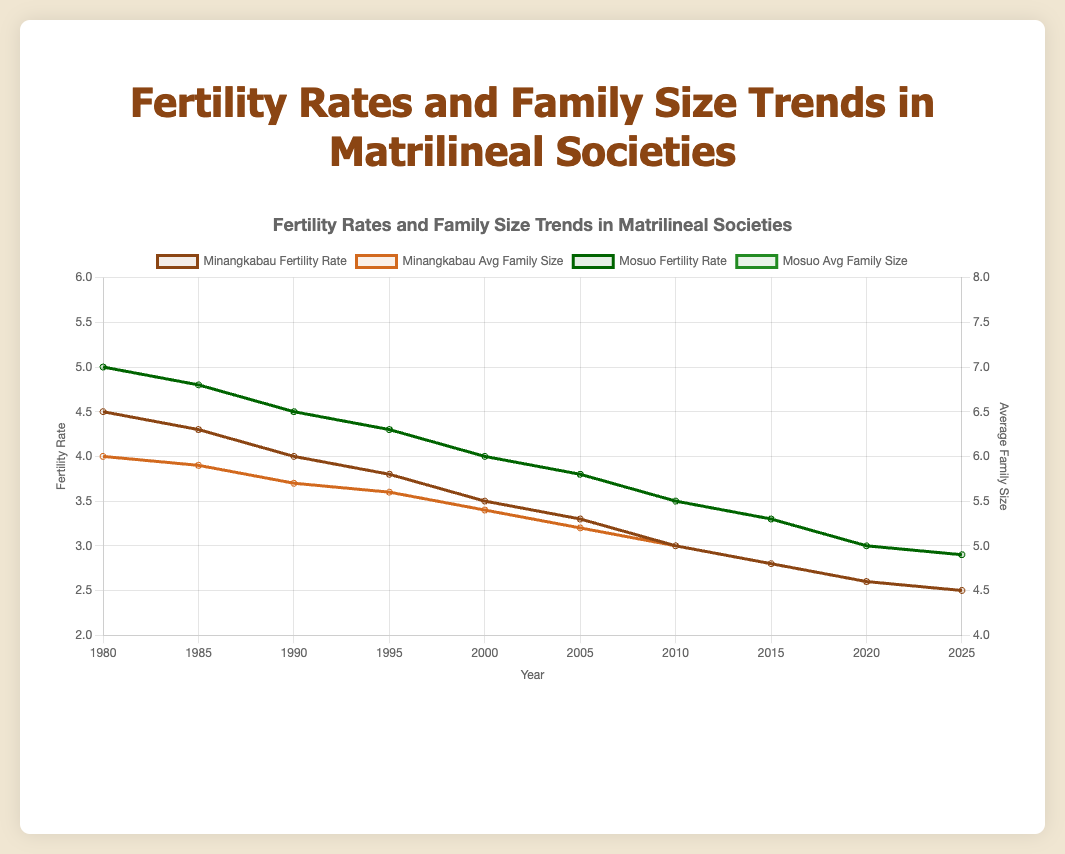What year does the Minangkabau society reach a fertility rate of 3.3? The Minangkabau society's fertility rate in 2005 is 3.3, as observed from the corresponding point on the curve.
Answer: 2005 Which society had a higher fertility rate in the year 2000, and what is the difference between them? In 2000, the Minangkabau fertility rate is 3.5, and the Mosuo fertility rate is 4.0. The difference is 4.0 - 3.5 = 0.5.
Answer: Mosuo, 0.5 How does the average family size of the Minangkabau society change from 1980 to 2025? The Minangkabau society's average family size decreases from 6 in 1980 to 4.5 in 2025, indicating a decline over the years.
Answer: It decreases Which society shows a greater decline in fertility rate from 1980 to 2025, and by how much? For Minangkabau, the decline is 4.5 - 2.5 = 2.0. For Mosuo, the decline is 5.0 - 2.9 = 2.1. Mosuo shows a greater decline.
Answer: Mosuo, 2.1 In 2010, compare the Minangkabau and Mosuo's average family size and determine the difference. In 2010, Minangkabau has an average family size of 5.0, and Mosuo has an average family size of 5.5. The difference is 5.5 - 5.0 = 0.5.
Answer: 0.5 Which society had an average family size of 5.0 and in what year? According to the chart, both the Minangkabau and Mosuo societies had an average family size of 5.0 in different years. Minangkabau in 2010 and Mosuo in 2020.
Answer: Minangkabau in 2010, Mosuo in 2020 What is the relationship between the fertility rate and average family size for the Minangkabau society over the years? Both the fertility rate and average family size for the Minangkabau society show a decreasing trend from 1980 to 2025.
Answer: Both decrease In which year did the Mosuo society reach a fertility rate of 3.8? The fertility rate of the Mosuo society reached 3.8 in the year 2005, as indicated by the specific point on the graph.
Answer: 2005 What is the difference between the Minangkabau and Mosuo average family sizes in 1995? In 1995, the Minangkabau average family size is 5.6, and the Mosuo average family size is 6.3. The difference is 6.3 - 5.6 = 0.7.
Answer: 0.7 Between 1980 and 2025, how does the trend in average family size change compare between the two societies visually? Visually, both societies show a decreasing trend in average family size from 1980 to 2025. However, the Mosuo society begins at a higher average and decreases at a roughly similar rate as the Minangkabau society.
Answer: Both decrease; Mosuo starts higher 